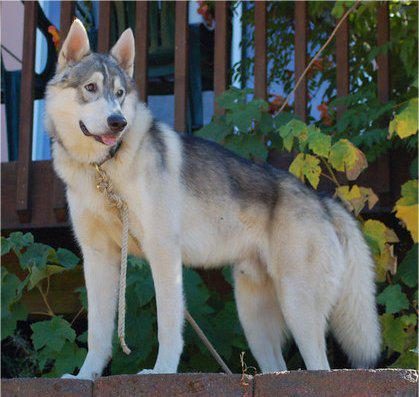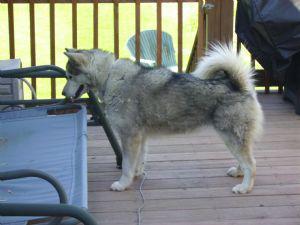The first image is the image on the left, the second image is the image on the right. For the images displayed, is the sentence "The right image shows a husky standing in profile with its tail curled inward, and the left image shows a dog on a rope in a standing pose in front of an outdoor 'wall'." factually correct? Answer yes or no. Yes. The first image is the image on the left, the second image is the image on the right. Assess this claim about the two images: "The dog in one of the images is standing on the wood planks of a deck outside.". Correct or not? Answer yes or no. Yes. 